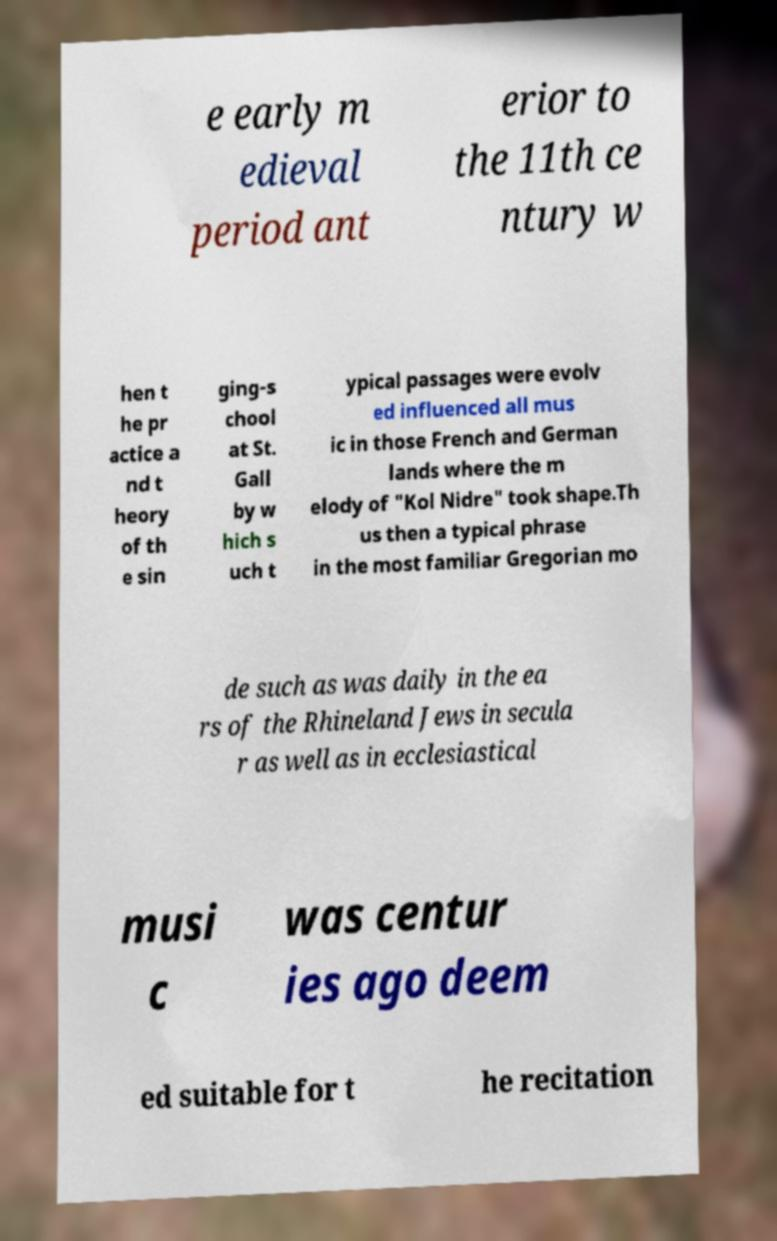Can you read and provide the text displayed in the image?This photo seems to have some interesting text. Can you extract and type it out for me? e early m edieval period ant erior to the 11th ce ntury w hen t he pr actice a nd t heory of th e sin ging-s chool at St. Gall by w hich s uch t ypical passages were evolv ed influenced all mus ic in those French and German lands where the m elody of "Kol Nidre" took shape.Th us then a typical phrase in the most familiar Gregorian mo de such as was daily in the ea rs of the Rhineland Jews in secula r as well as in ecclesiastical musi c was centur ies ago deem ed suitable for t he recitation 